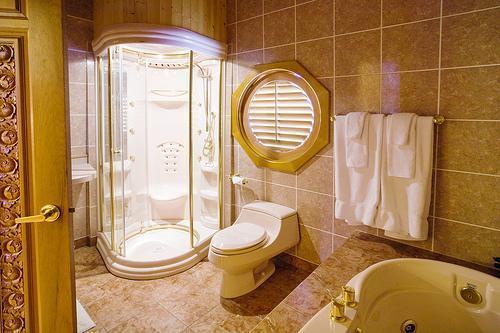How many toilets are there?
Give a very brief answer. 1. 